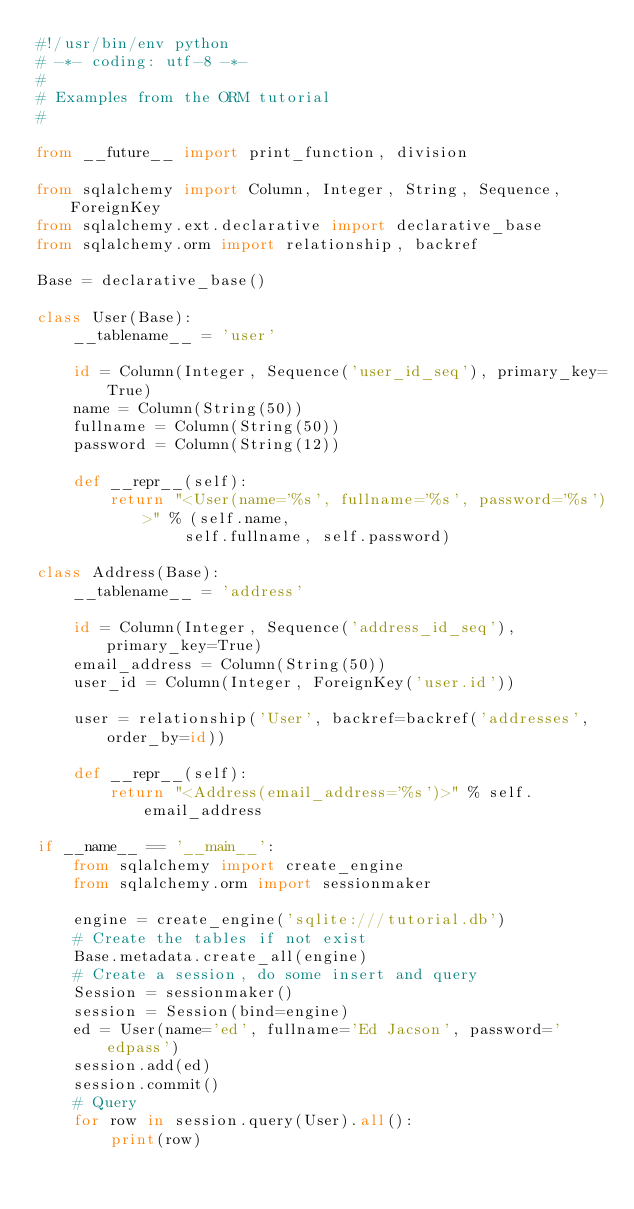Convert code to text. <code><loc_0><loc_0><loc_500><loc_500><_Python_>#!/usr/bin/env python
# -*- coding: utf-8 -*-
#
# Examples from the ORM tutorial
#

from __future__ import print_function, division

from sqlalchemy import Column, Integer, String, Sequence, ForeignKey
from sqlalchemy.ext.declarative import declarative_base
from sqlalchemy.orm import relationship, backref

Base = declarative_base()

class User(Base):
    __tablename__ = 'user'

    id = Column(Integer, Sequence('user_id_seq'), primary_key=True)
    name = Column(String(50))
    fullname = Column(String(50))
    password = Column(String(12))

    def __repr__(self):
        return "<User(name='%s', fullname='%s', password='%s')>" % (self.name,
                self.fullname, self.password)

class Address(Base):
    __tablename__ = 'address'

    id = Column(Integer, Sequence('address_id_seq'), primary_key=True)
    email_address = Column(String(50))
    user_id = Column(Integer, ForeignKey('user.id'))

    user = relationship('User', backref=backref('addresses', order_by=id))

    def __repr__(self):
        return "<Address(email_address='%s')>" % self.email_address

if __name__ == '__main__':
    from sqlalchemy import create_engine
    from sqlalchemy.orm import sessionmaker

    engine = create_engine('sqlite:///tutorial.db')
    # Create the tables if not exist
    Base.metadata.create_all(engine)
    # Create a session, do some insert and query
    Session = sessionmaker()
    session = Session(bind=engine)
    ed = User(name='ed', fullname='Ed Jacson', password='edpass')
    session.add(ed)
    session.commit()
    # Query
    for row in session.query(User).all():
        print(row)
</code> 